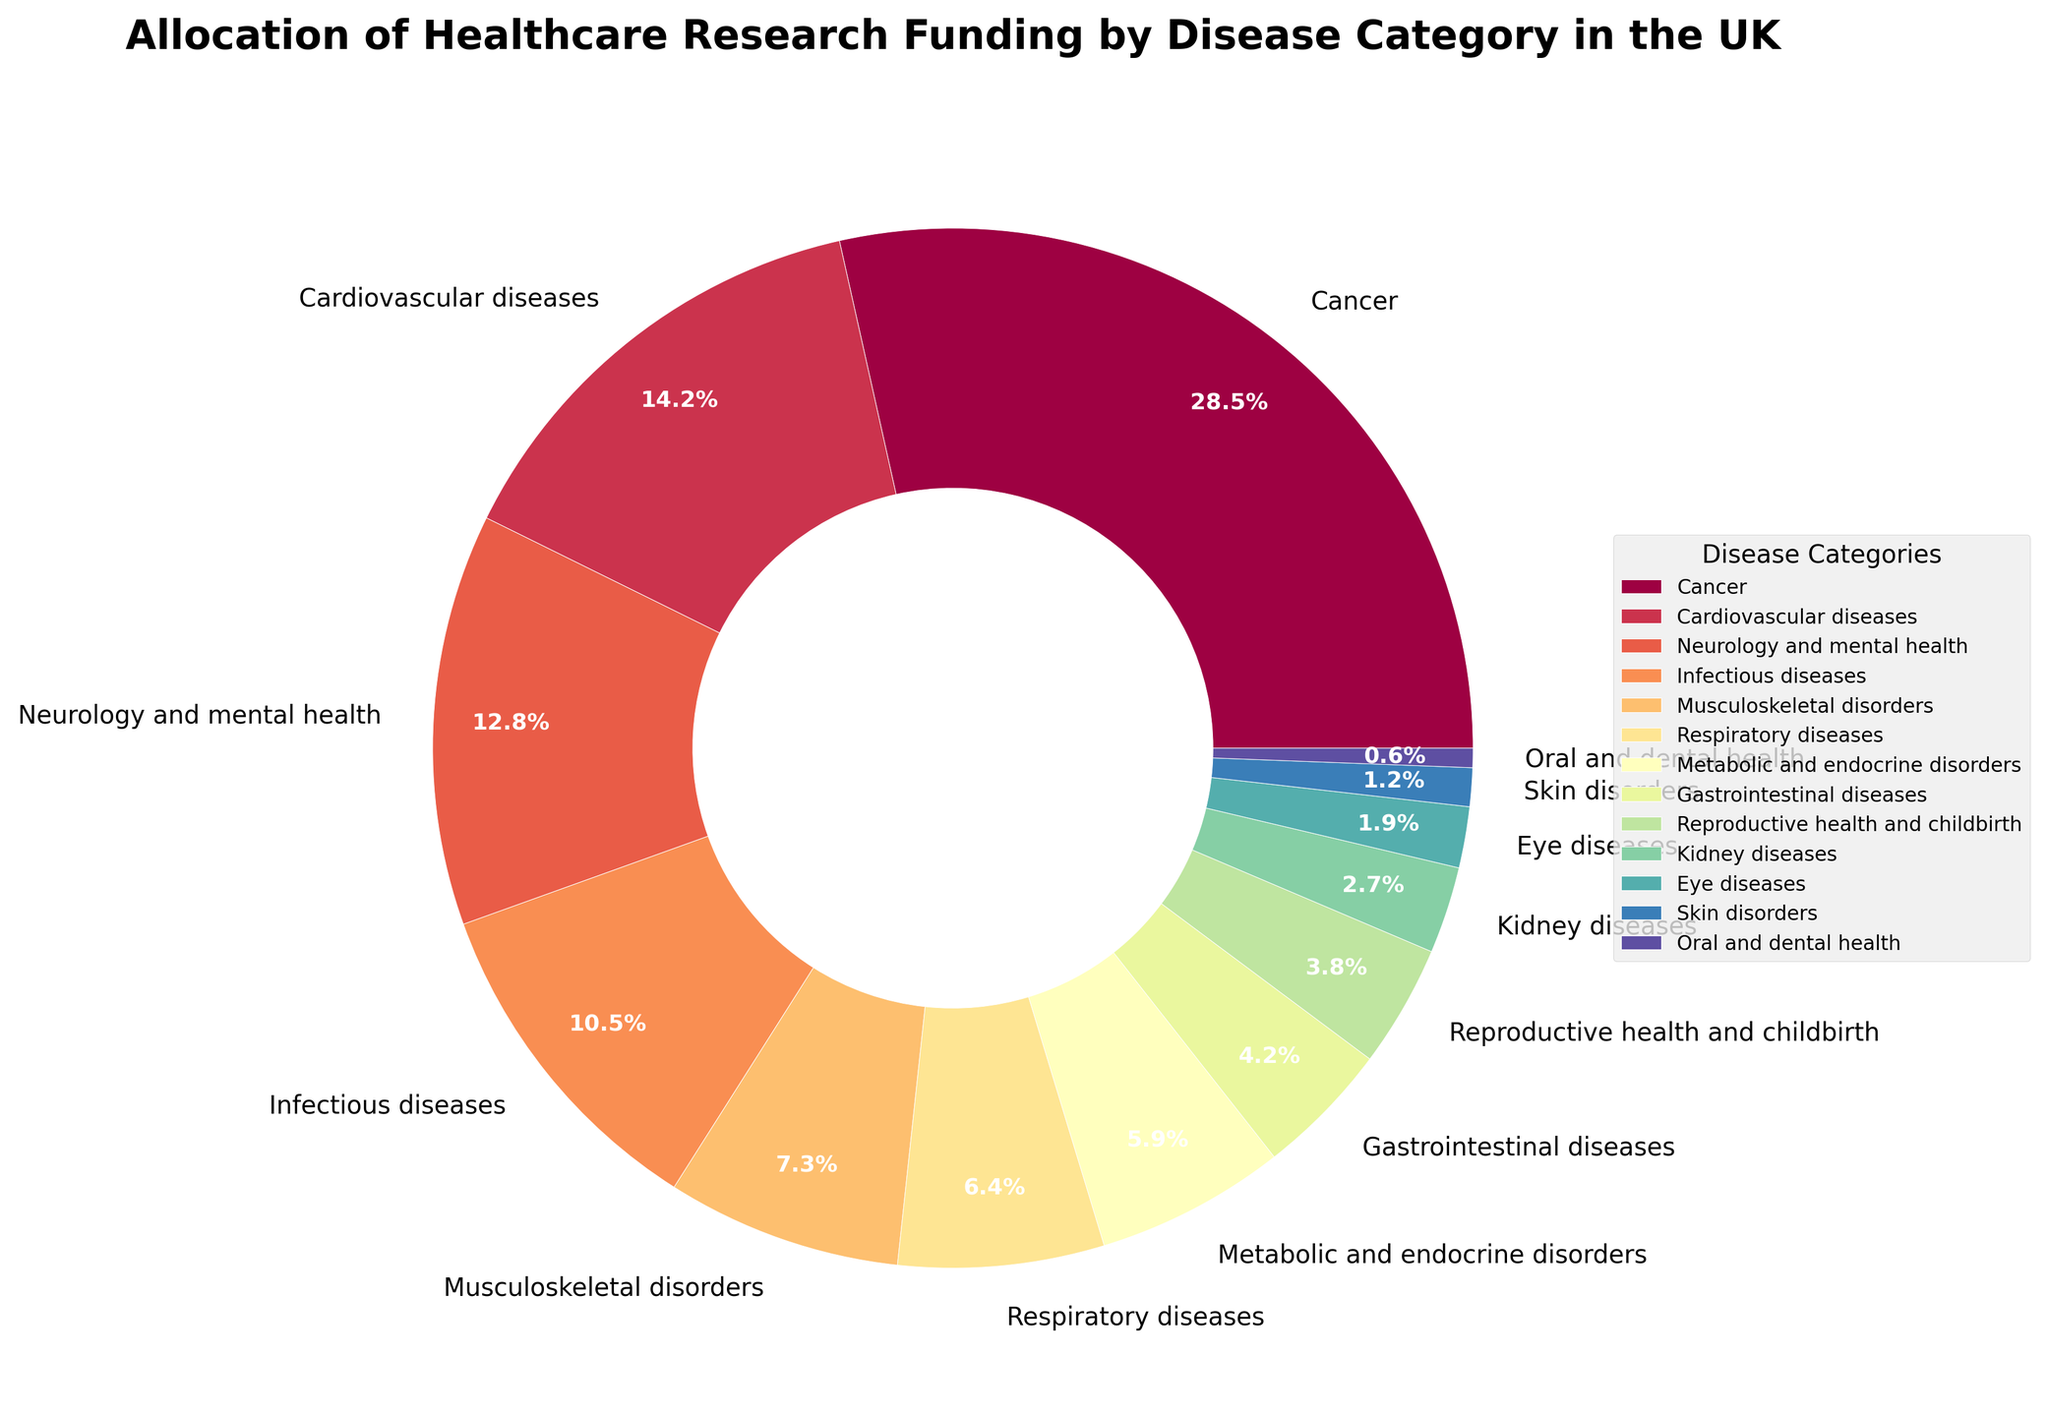Which disease category receives the highest percentage of healthcare research funding? The slice of the pie chart corresponding to "Cancer" is the largest, showing it receives the highest percentage of healthcare research funding.
Answer: Cancer What is the combined percentage of funding for Cardiovascular diseases and Neurology and mental health? Add the funding percentages for Cardiovascular diseases (14.2%) and Neurology and mental health (12.8%): 14.2 + 12.8 = 27.0.
Answer: 27.0 How much more funding does Cancer receive compared to Infectious diseases? Subtract the funding percentage of Infectious diseases (10.5%) from Cancer (28.5%): 28.5 - 10.5 = 18.0.
Answer: 18.0 Which disease categories receive less than 5% of the total funding? The slices representing Gastrointestinal diseases (4.2%), Reproductive health and childbirth (3.8%), Kidney diseases (2.7%), Eye diseases (1.9%), Skin disorders (1.2%), and Oral and dental health (0.6%) are all smaller than 5%.
Answer: Gastrointestinal diseases, Reproductive health and childbirth, Kidney diseases, Eye diseases, Skin disorders, Oral and dental health What is the total funding percentage for the three disease categories with the smallest allocations? Sum the percentages of Oral and dental health (0.6%), Skin disorders (1.2%), and Eye diseases (1.9%): 0.6 + 1.2 + 1.9 = 3.7.
Answer: 3.7 Does Neurology and mental health receive more funding than Musculoskeletal disorders? Compare the funding percentages: Neurology and mental health (12.8%) is higher than Musculoskeletal disorders (7.3%).
Answer: Yes What is the difference in funding percentage between Respiratory diseases and Kidney diseases? Subtract the funding percentage of Kidney diseases (2.7%) from Respiratory diseases (6.4%): 6.4 - 2.7 = 3.7.
Answer: 3.7 Among the categories listed, which one receives the least funding and what percentage is it? The smallest slice of the pie chart represents Oral and dental health, which receives 0.6% of the funding.
Answer: Oral and dental health, 0.6% How many disease categories receive more than 10% of the research funding? Count the categories with funding percentages above 10%: Cancer (28.5%), Cardiovascular diseases (14.2%), and Neurology and mental health (12.8%) = 3 categories.
Answer: 3 